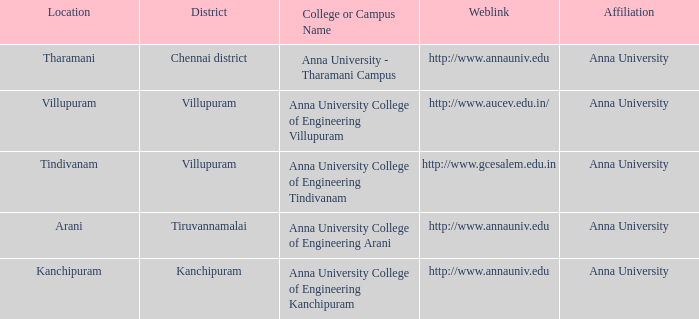What Weblink has a College or Campus Name of anna university college of engineering tindivanam? Http://www.gcesalem.edu.in. 